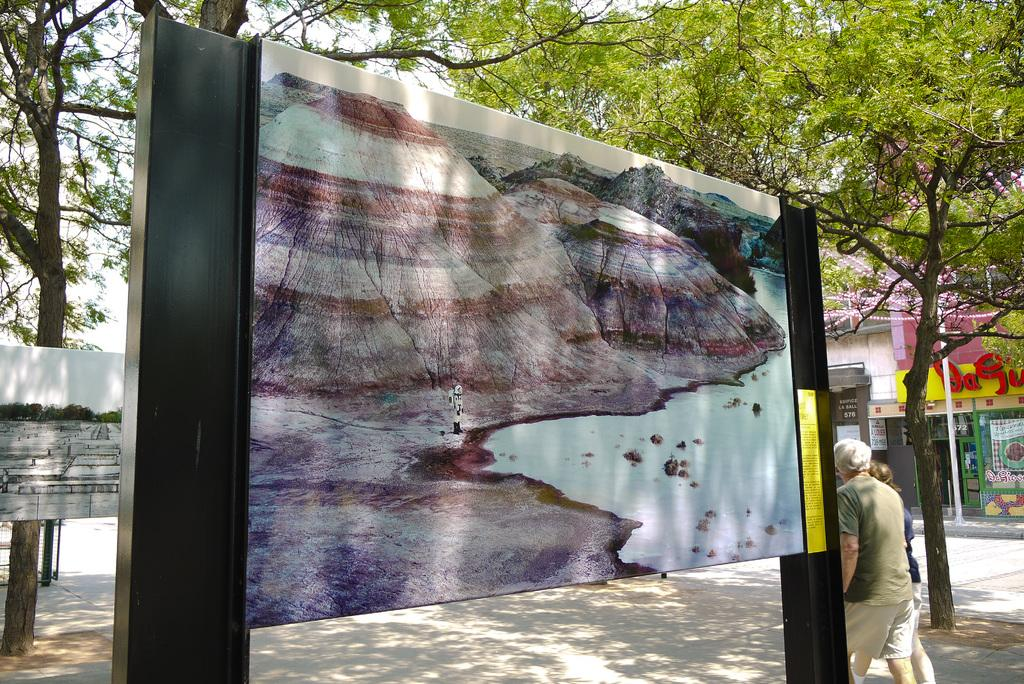What is located in the center of the image? There are sign boards and poles in the center of the image. What are the two persons in the image doing? The two persons are walking in the image. What can be seen in the background of the image? There is sky, clouds, trees, at least one building, a wall, banners, additional poles, glass, and a road visible in the background of the image. Can you tell me where the kitty is hiding in the image? There is no kitty present in the image. What type of reward is being offered on the sign boards in the image? The image does not provide information about any rewards being offered on the sign boards. 